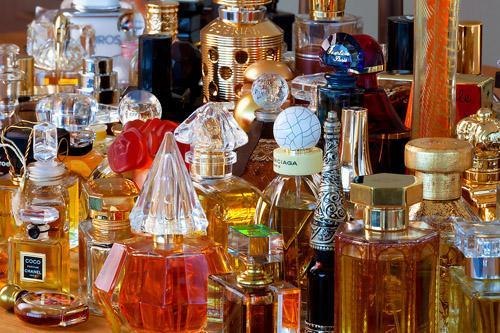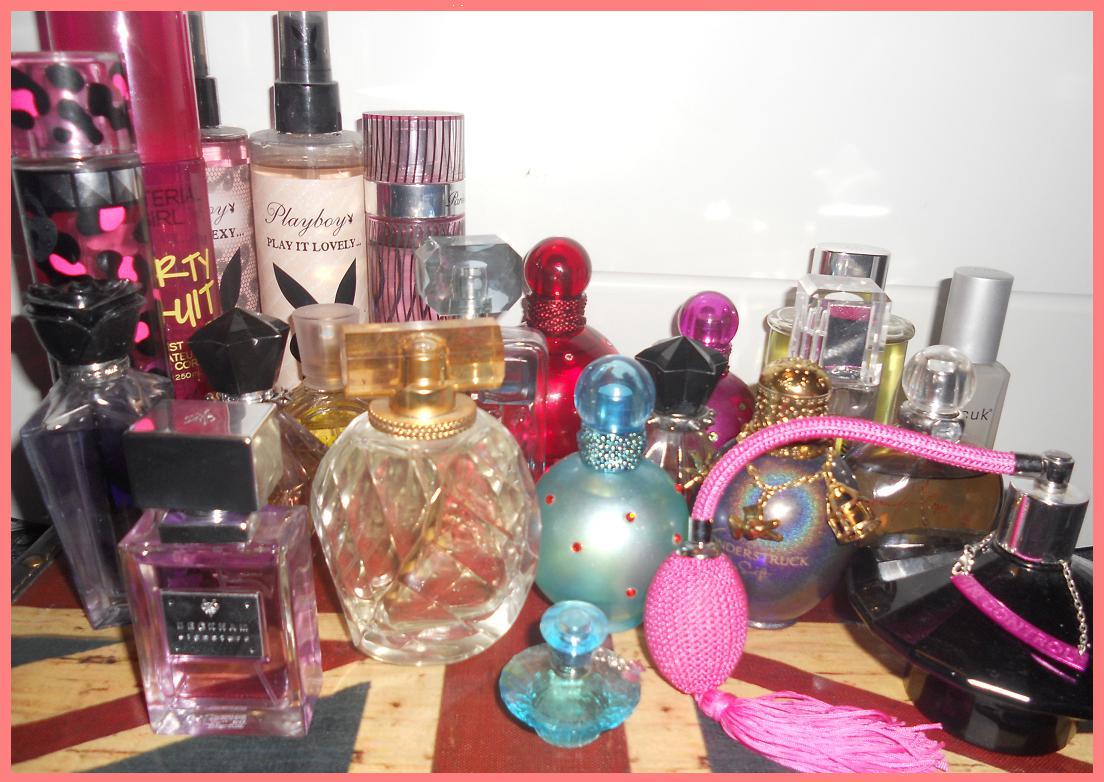The first image is the image on the left, the second image is the image on the right. Assess this claim about the two images: "The image on the left boasts less than ten items.". Correct or not? Answer yes or no. No. The first image is the image on the left, the second image is the image on the right. Evaluate the accuracy of this statement regarding the images: "The collection of fragrance bottles on the right includes a squat round black bottle with a pink tube and bulb attached.". Is it true? Answer yes or no. Yes. 